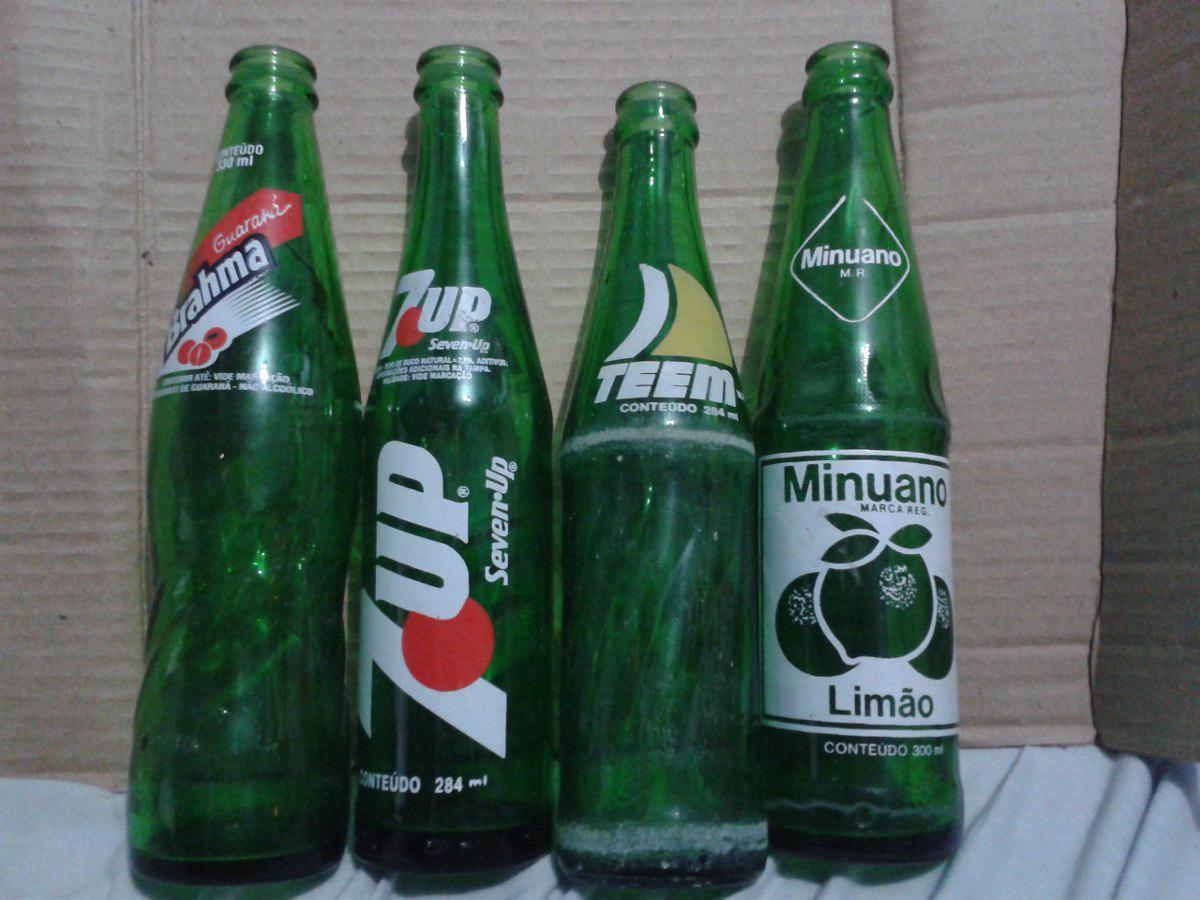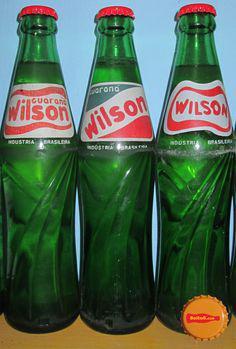The first image is the image on the left, the second image is the image on the right. Given the left and right images, does the statement "Six or fewer bottles are visible." hold true? Answer yes or no. No. The first image is the image on the left, the second image is the image on the right. Given the left and right images, does the statement "There are exactly two green bottles in the right image, and multiple green bottles with a clear bottle in the left image." hold true? Answer yes or no. No. 